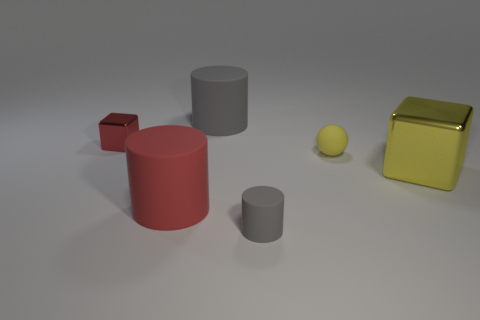Subtract all tiny gray matte cylinders. How many cylinders are left? 2 Subtract 2 cubes. How many cubes are left? 0 Add 3 large purple rubber cylinders. How many objects exist? 9 Subtract all yellow cubes. How many cubes are left? 1 Subtract all yellow cylinders. How many red cubes are left? 1 Subtract all rubber objects. Subtract all green matte balls. How many objects are left? 2 Add 4 rubber spheres. How many rubber spheres are left? 5 Add 6 red rubber cubes. How many red rubber cubes exist? 6 Subtract 0 red spheres. How many objects are left? 6 Subtract all cubes. How many objects are left? 4 